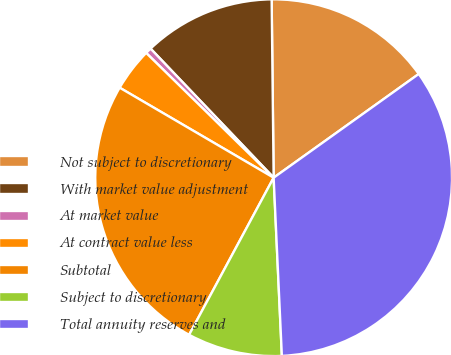Convert chart. <chart><loc_0><loc_0><loc_500><loc_500><pie_chart><fcel>Not subject to discretionary<fcel>With market value adjustment<fcel>At market value<fcel>At contract value less<fcel>Subtotal<fcel>Subject to discretionary<fcel>Total annuity reserves and<nl><fcel>15.3%<fcel>11.94%<fcel>0.55%<fcel>3.91%<fcel>25.56%<fcel>8.59%<fcel>34.14%<nl></chart> 